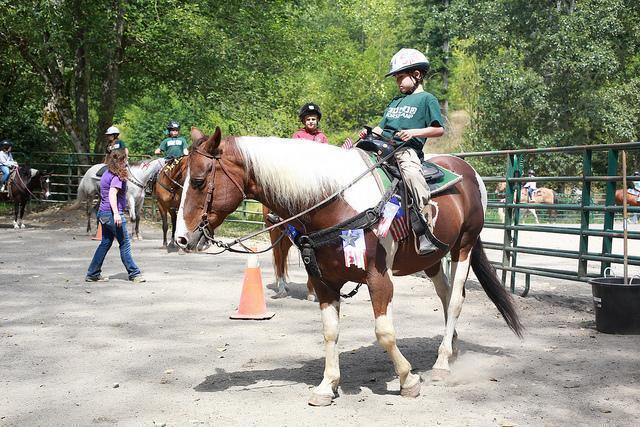Which person works at this facility?
Answer the question by selecting the correct answer among the 4 following choices.
Options: Red top, back kid, front kid, purple shirt. Purple shirt. 